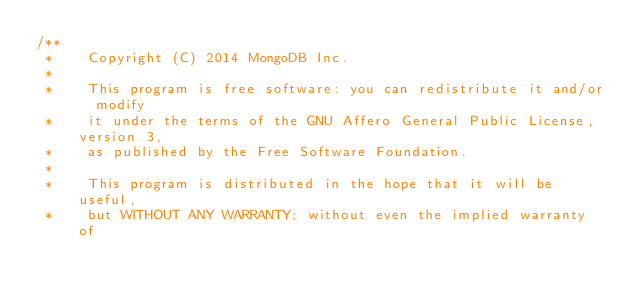<code> <loc_0><loc_0><loc_500><loc_500><_C++_>/**
 *    Copyright (C) 2014 MongoDB Inc.
 *
 *    This program is free software: you can redistribute it and/or  modify
 *    it under the terms of the GNU Affero General Public License, version 3,
 *    as published by the Free Software Foundation.
 *
 *    This program is distributed in the hope that it will be useful,
 *    but WITHOUT ANY WARRANTY; without even the implied warranty of</code> 